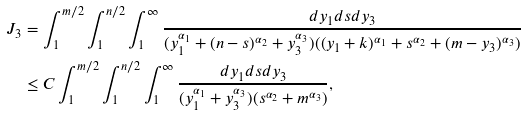Convert formula to latex. <formula><loc_0><loc_0><loc_500><loc_500>J _ { 3 } & = \int _ { 1 } ^ { m / 2 } \int _ { 1 } ^ { n / 2 } \int _ { 1 } ^ { \infty } \frac { d y _ { 1 } d s d y _ { 3 } } { ( y _ { 1 } ^ { \alpha _ { 1 } } + ( n - s ) ^ { \alpha _ { 2 } } + y _ { 3 } ^ { \alpha _ { 3 } } ) ( ( y _ { 1 } + k ) ^ { \alpha _ { 1 } } + s ^ { \alpha _ { 2 } } + ( m - y _ { 3 } ) ^ { \alpha _ { 3 } } ) } \\ & \leq C \int _ { 1 } ^ { m / 2 } \int _ { 1 } ^ { n / 2 } \int _ { 1 } ^ { \infty } \frac { d y _ { 1 } d s d y _ { 3 } } { ( y _ { 1 } ^ { \alpha _ { 1 } } + y _ { 3 } ^ { \alpha _ { 3 } } ) ( s ^ { \alpha _ { 2 } } + m ^ { \alpha _ { 3 } } ) } ,</formula> 